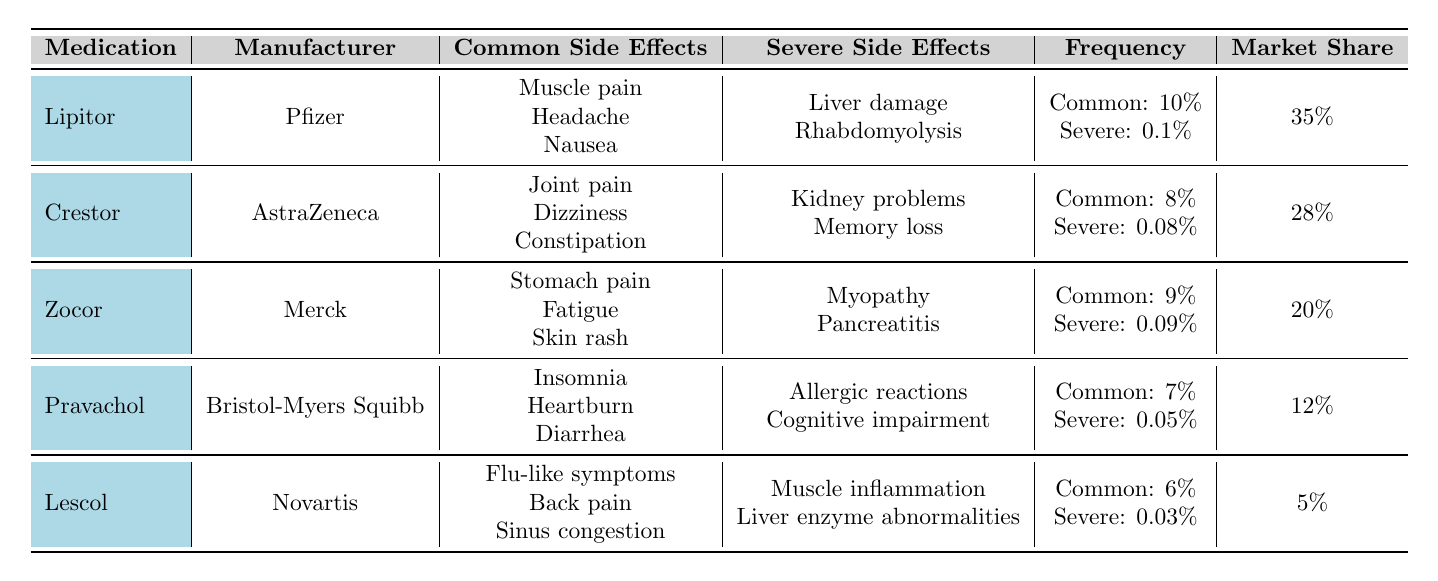What are the common side effects of Lipitor? Lipitor has three common side effects listed: Muscle pain, Headache, and Nausea.
Answer: Muscle pain, Headache, Nausea Which medication has the highest market share? Lipitor has a market share of 35%, which is the highest among the listed medications.
Answer: Lipitor What is the frequency of severe side effects for Crestor? The frequency of severe side effects for Crestor is 0.08%.
Answer: 0.08% How many medications have a frequency of common side effects greater than 8%? Lipitor (10%) and Zocor (9%) both have common side effects frequencies greater than 8%. That makes a total of 2 medications.
Answer: 2 Are the severe side effects for Pravachol more severe than those for Lescol? Pravachol's severe side effects include Allergic reactions and Cognitive impairment, while Lescol's include Muscle inflammation and Liver enzyme abnormalities. The severity cannot be directly compared as the descriptions differ, thus this is not strictly true.
Answer: No What is the total market share of medications with a frequency of common side effects below 8%? Lescol (5%) and Pravachol (12%) have common side effects below 8%. Adding their market shares, we get 5% + 12% = 17%.
Answer: 17% Which medication has the lowest frequency of severe side effects? Lescol has the lowest frequency of severe side effects at 0.03%.
Answer: 0.03% If you combined the market shares of Crestor and Pravachol, what would the total be? Crestor has a market share of 28% and Pravachol has 12%, so combining them gives 28% + 12% = 40%.
Answer: 40% Does Zocor have any common side effects that are also found in Lipitor? Zocor has common side effects like Stomach pain, Fatigue, and Skin rash, none of which are shared with Lipitor's common side effects of Muscle pain, Headache, and Nausea.
Answer: No Which medication has a higher frequency of common side effects: Zocor or Crestor? Zocor has a frequency of common side effects at 9%, while Crestor has 8%. Thus, Zocor has a higher frequency.
Answer: Zocor 